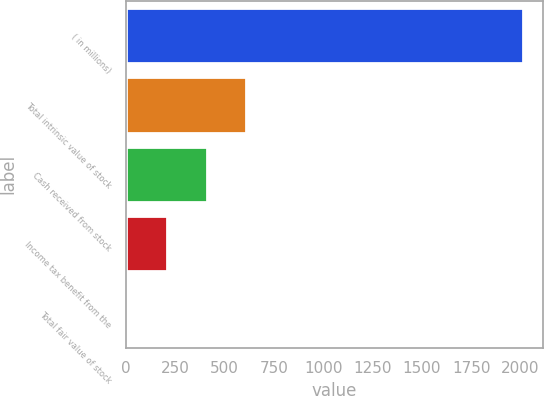Convert chart. <chart><loc_0><loc_0><loc_500><loc_500><bar_chart><fcel>( in millions)<fcel>Total intrinsic value of stock<fcel>Cash received from stock<fcel>Income tax benefit from the<fcel>Total fair value of stock<nl><fcel>2014<fcel>611.2<fcel>410.8<fcel>210.4<fcel>10<nl></chart> 